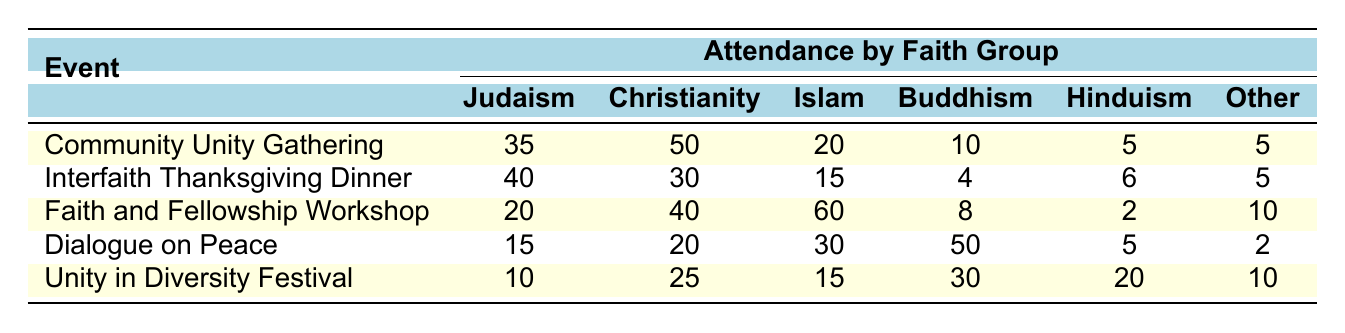What was the attendance of Christianity at the "Community Unity Gathering"? The attendance for Christianity at the "Community Unity Gathering" is directly listed in the table under the relevant event. It shows a count of 50.
Answer: 50 What is the total attendance from the Judaism group across all events? To find the total for Judaism, I add the values: 35 (Community Unity Gathering) + 40 (Interfaith Thanksgiving Dinner) + 20 (Faith and Fellowship Workshop) + 15 (Dialogue on Peace) + 10 (Unity in Diversity Festival) = 120.
Answer: 120 Did more people from Islam attend the "Unity in Diversity Festival" compared to the "Dialogue on Peace"? The table shows that 15 people from Islam attended the "Unity in Diversity Festival", while 30 attended the "Dialogue on Peace". Since 15 is less than 30, the answer is no.
Answer: No What is the average attendance of Buddhism across all events? To calculate the average attendance for Buddhism, we add the attendance values: 10 (Community Unity Gathering) + 4 (Interfaith Thanksgiving Dinner) + 8 (Faith and Fellowship Workshop) + 50 (Dialogue on Peace) + 30 (Unity in Diversity Festival) = 102. There are 5 events, so we divide: 102/5 = 20.4.
Answer: 20.4 Which event had the highest attendance from the Islam group? By examining the attendance values for Islam from each event, the highest attendance is 60 from the "Faith and Fellowship Workshop".
Answer: Faith and Fellowship Workshop What is the difference between the highest number of attendees from Christianity and the lowest number from the same group? The highest attendance for Christianity is 50 (from the "Community Unity Gathering"), while the lowest is 30 (from the "Interfaith Thanksgiving Dinner"). The difference is 50 - 30 = 20.
Answer: 20 How many total attendees were there at the "Interfaith Thanksgiving Dinner"? To find the total attendance for the "Interfaith Thanksgiving Dinner", we sum the attendance from all faith groups: 40 (Judaism) + 30 (Christianity) + 15 (Islam) + 4 (Buddhism) + 6 (Hinduism) + 5 (Other) = 100.
Answer: 100 Which faith group had the least attendance at the "Dialogue on Peace"? Looking at the attendance for each faith group at the "Dialogue on Peace", Hinduism had the least attendance with a count of 5.
Answer: Hinduism What is the combined attendance from the "Community Unity Gathering" and the "Unity in Diversity Festival" for Hinduism? The attendance for Hinduism in both events is 5 (from the "Community Unity Gathering") and 20 (from the "Unity in Diversity Festival"). Adding these gives 5 + 20 = 25.
Answer: 25 Was the total attendance from Other faiths higher at the "Faith and Fellowship Workshop" compared to the "Dialogue on Peace"? At the "Faith and Fellowship Workshop", the Other faiths group attendance was 10, while at the "Dialogue on Peace", it was 2. Since 10 is greater than 2, the answer is yes.
Answer: Yes 